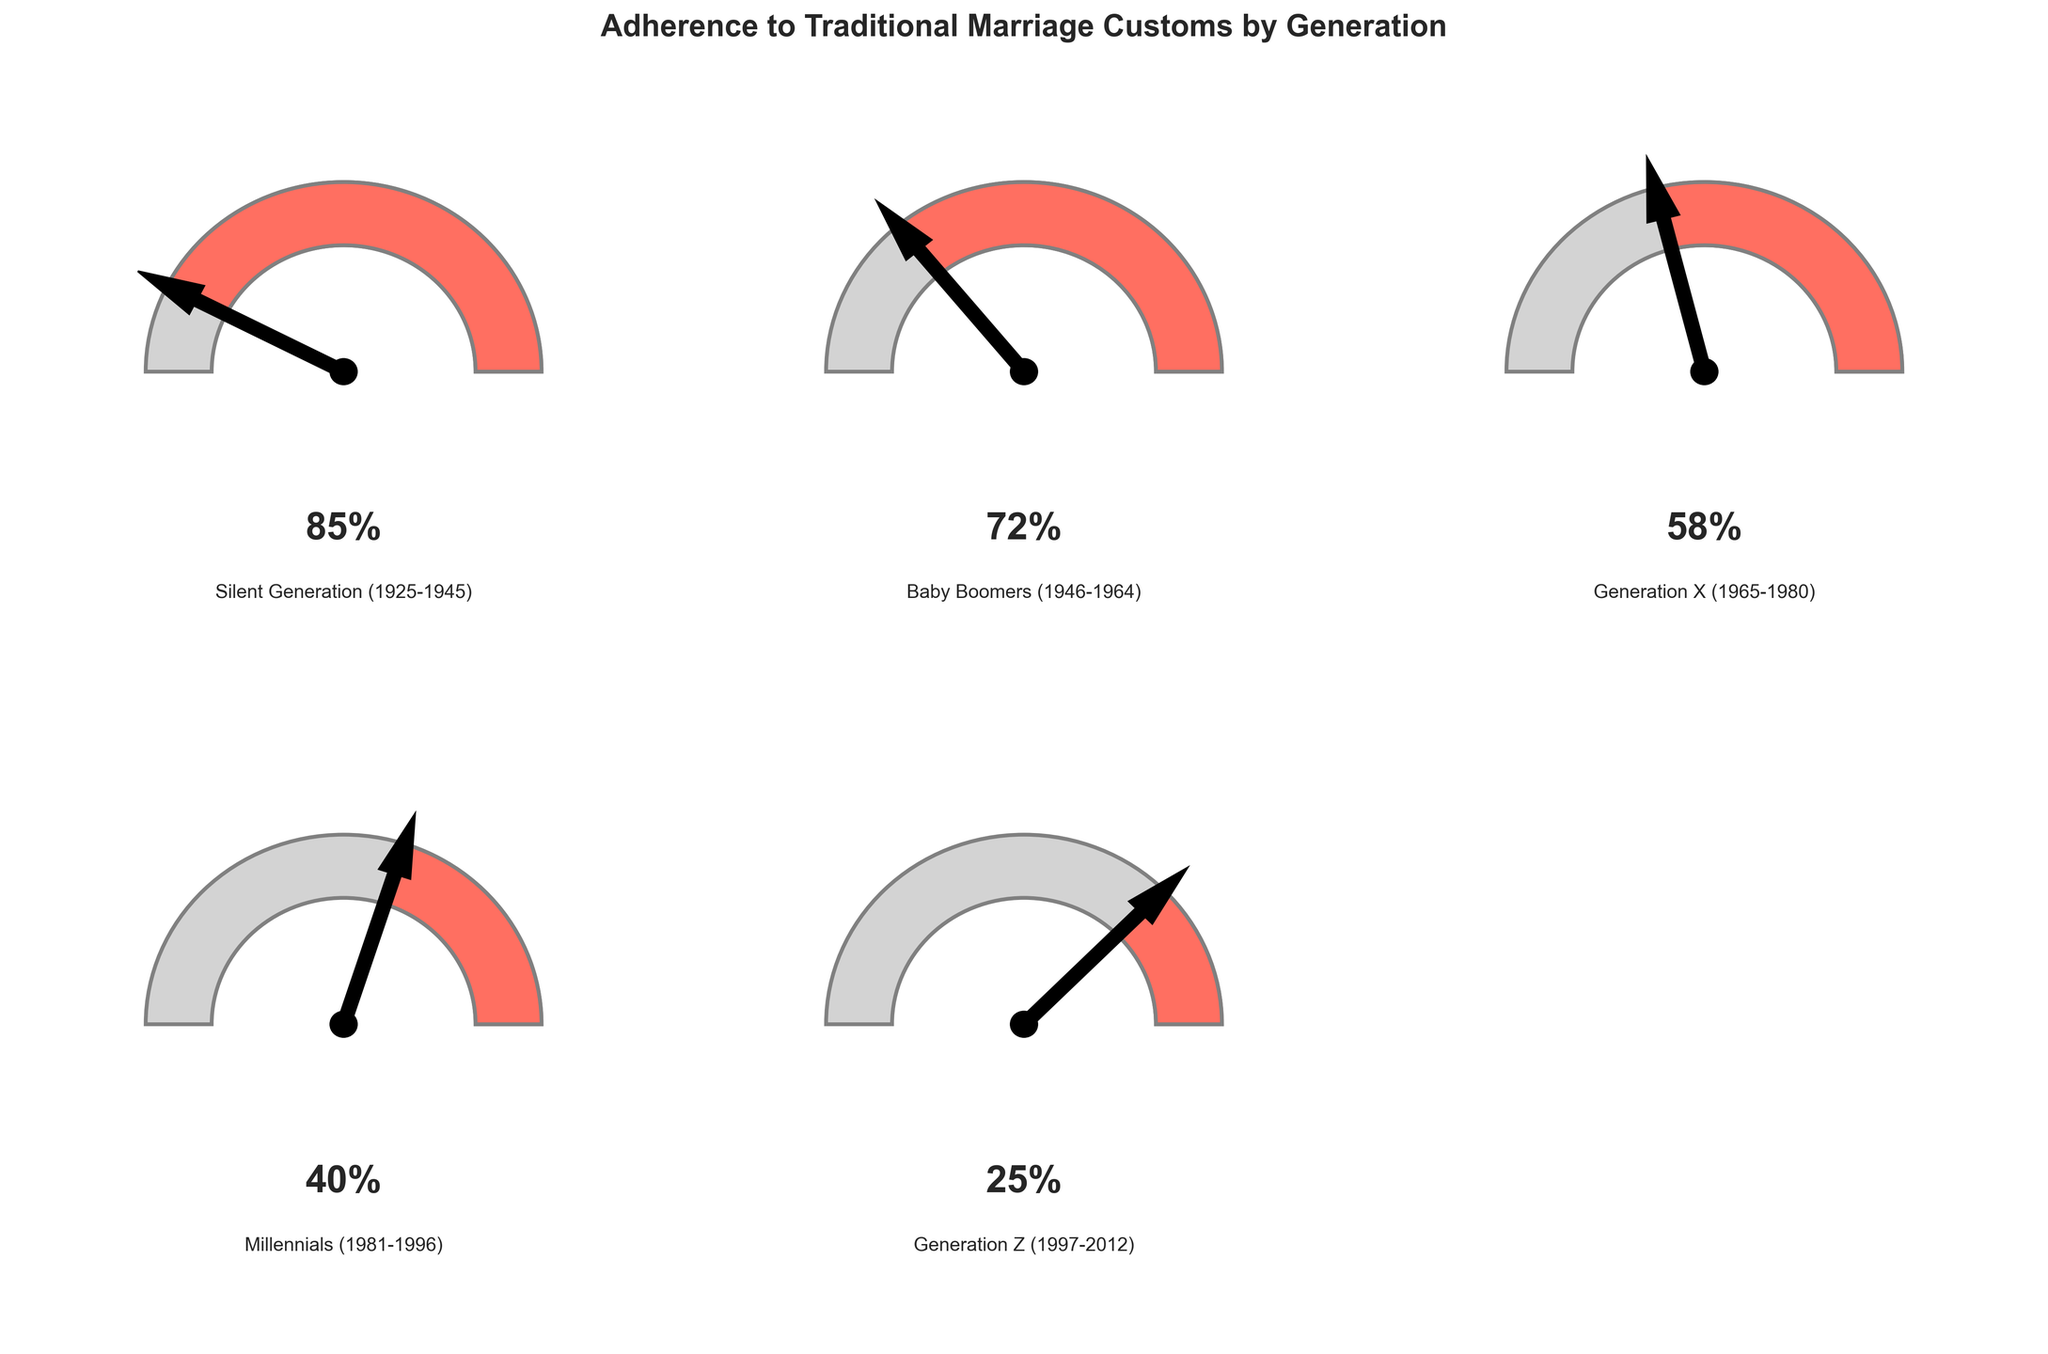What is the adherence percentage of Millennials to traditional marriage customs? Refer to the gauge chart for Millennials. It shows 40% adherence.
Answer: 40% Which generation shows the highest adherence to traditional marriage customs? The gauge chart for the Silent Generation shows the highest adherence at 85%.
Answer: Silent Generation How does the adherence percentage of Generation X compare to that of Baby Boomers? The gauge chart for Generation X shows 58% adherence, while Baby Boomers show 72%. Thus, Baby Boomers have a higher adherence by 14%.
Answer: Baby Boomers have higher adherence by 14% What's the median adherence percentage across all generations? To find the median, first list the percentages in ascending order: 25, 40, 58, 72, 85. The median value is the third number in this ordered list, which is 58%.
Answer: 58% Which generation has the lowest adherence to traditional marriage customs? The gauge chart for Generation Z shows the lowest adherence at 25%.
Answer: Generation Z What's the difference in adherence percentage between the Silent Generation and Generation Z? The Silent Generation has an adherence of 85%, and Generation Z has 25%. The difference is 85 - 25 = 60%.
Answer: 60% Summarize the trend in adherence to traditional marriage customs across generations. The adherence percentage decreases progressively from older to younger generations: Silent Generation (85%), Baby Boomers (72%), Generation X (58%), Millennials (40%), and Generation Z (25%).
Answer: The trend is a decreasing adherence Which two generations have adherence percentages closest to each other? The adherence percentages are Silent Generation (85%), Baby Boomers (72%), Generation X (58%), Millennials (40%), and Generation Z (25%). The closest values are those of Generation X and Millennials (58% and 40%, respectively) with a difference of 18%.
Answer: Generation X and Millennials What is the average adherence percentage across all generations? The adherence percentages are 85, 72, 58, 40, and 25. Sum them up: 85 + 72 + 58 + 40 + 25 = 280. There are 5 generations, so the average is 280 / 5 = 56%.
Answer: 56% 